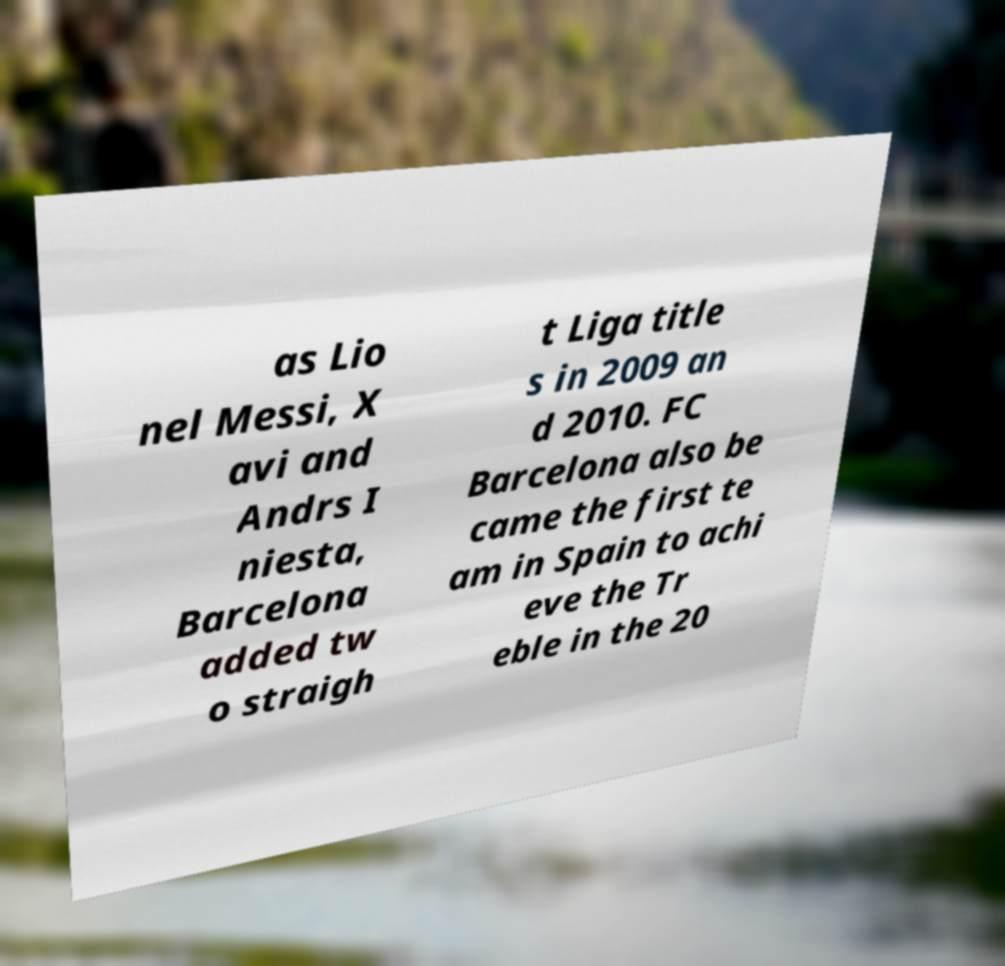Please identify and transcribe the text found in this image. as Lio nel Messi, X avi and Andrs I niesta, Barcelona added tw o straigh t Liga title s in 2009 an d 2010. FC Barcelona also be came the first te am in Spain to achi eve the Tr eble in the 20 